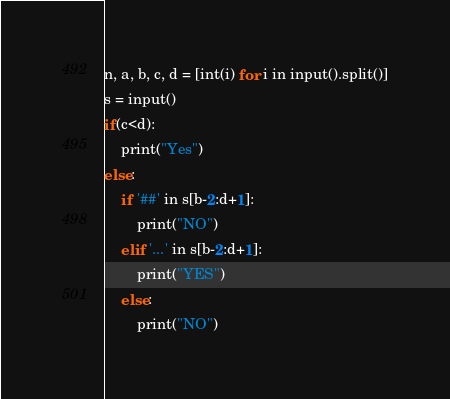Convert code to text. <code><loc_0><loc_0><loc_500><loc_500><_Python_>n, a, b, c, d = [int(i) for i in input().split()]
s = input()
if(c<d):
    print("Yes")
else:
    if '##' in s[b-2:d+1]:
        print("NO")
    elif '...' in s[b-2:d+1]:
        print("YES")
    else:
        print("NO")</code> 